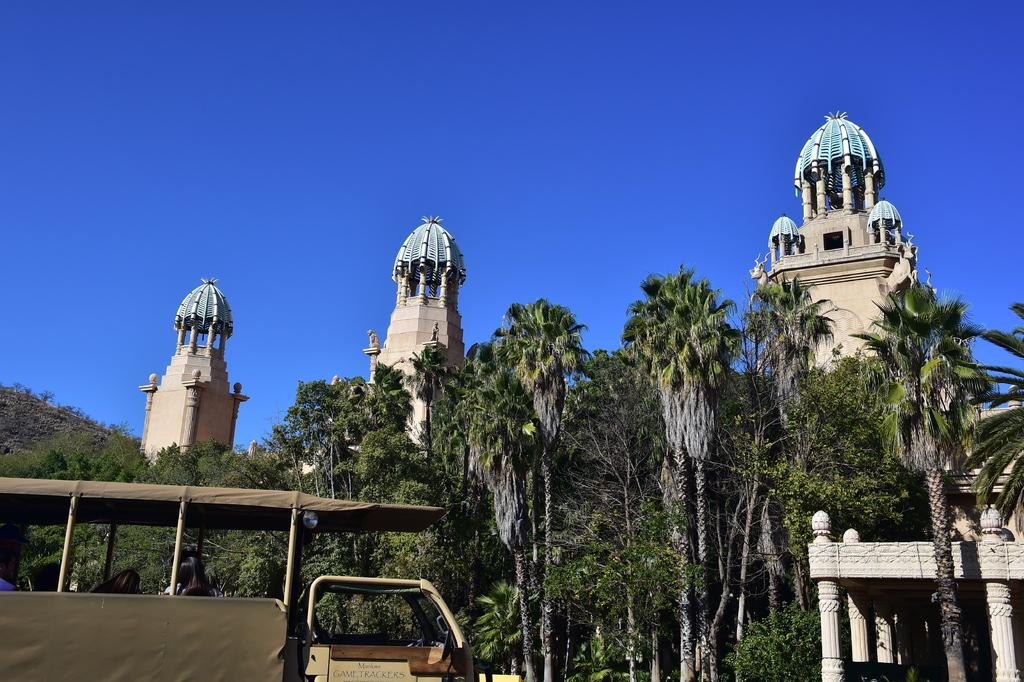What is located on the left side of the image? There is a vehicle on the left side of the image. What can be seen in the background of the image? There are trees, buildings, and a mountain in the background of the image. What is the color of the sky in the image? The sky is blue in the image. What word is written on the side of the vehicle in the image? There is no word written on the side of the vehicle in the image. How does the mountain heal its wound in the image? There is no wound on the mountain or any other element in the image. 